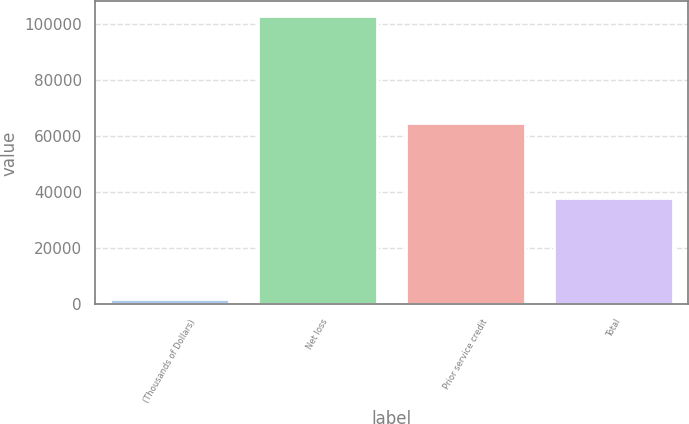Convert chart. <chart><loc_0><loc_0><loc_500><loc_500><bar_chart><fcel>(Thousands of Dollars)<fcel>Net loss<fcel>Prior service credit<fcel>Total<nl><fcel>2015<fcel>103039<fcel>64925<fcel>38114<nl></chart> 